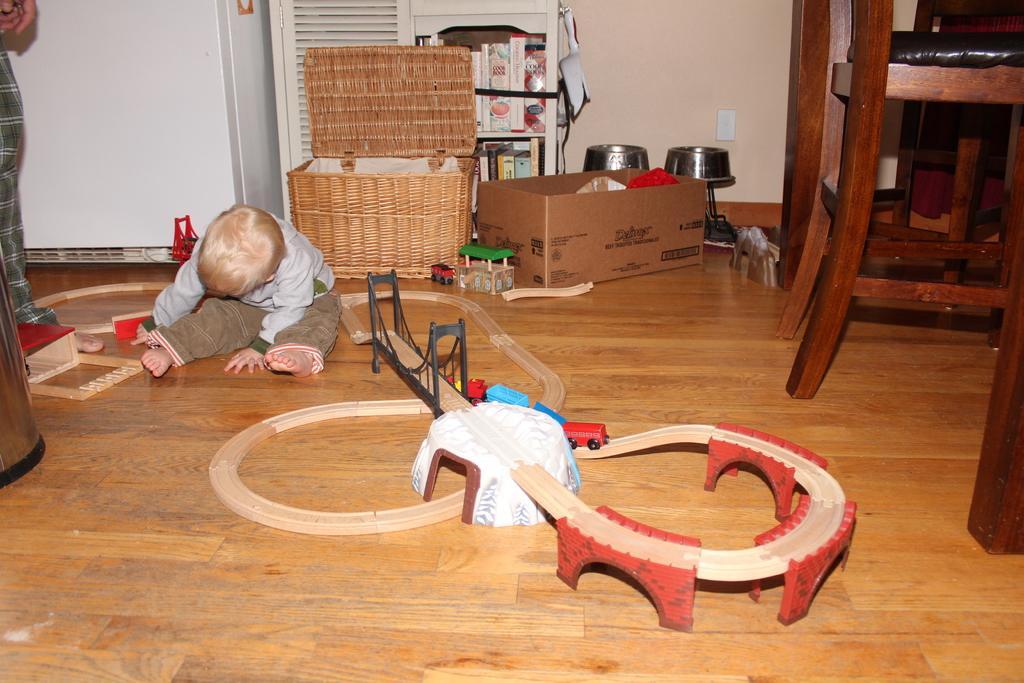Describe this image in one or two sentences. In this image, we can see a few people. Among them, we can see a kid sitting. We can see a wooden train track. We can see the ground with some objects like a cardboard box, a wooden basket, shelves with some objects. We can also see a white colored object. There are some chairs. We can see the wall. 